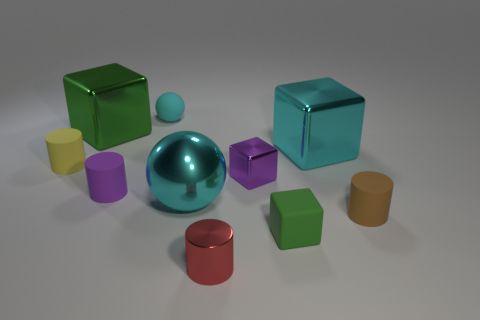Subtract all purple cubes. How many cubes are left? 3 Subtract all purple cubes. How many cubes are left? 3 Subtract all balls. How many objects are left? 8 Add 3 tiny cyan rubber things. How many tiny cyan rubber things exist? 4 Subtract 0 blue cubes. How many objects are left? 10 Subtract 4 cylinders. How many cylinders are left? 0 Subtract all blue cylinders. Subtract all red spheres. How many cylinders are left? 4 Subtract all blue balls. How many red cylinders are left? 1 Subtract all cyan spheres. Subtract all small brown matte objects. How many objects are left? 7 Add 3 tiny cylinders. How many tiny cylinders are left? 7 